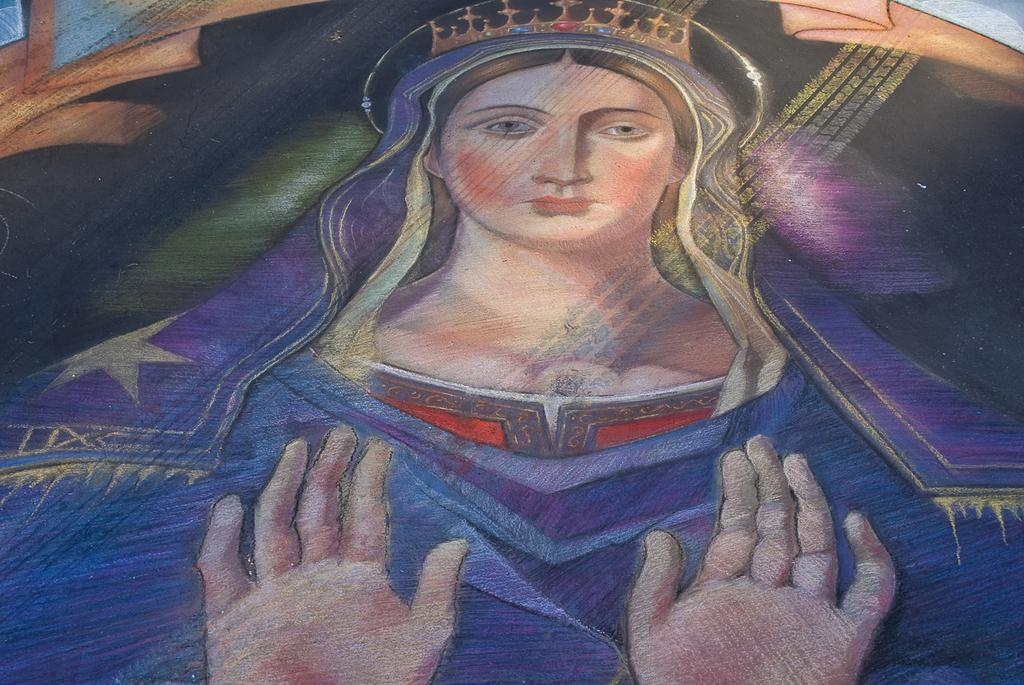What is the main subject of the painting in the image? There is a painting of a woman in the image. What type of steel is used to create the frame of the painting in the image? There is no information provided about the frame of the painting or the type of steel used, so it cannot be determined from the image. 